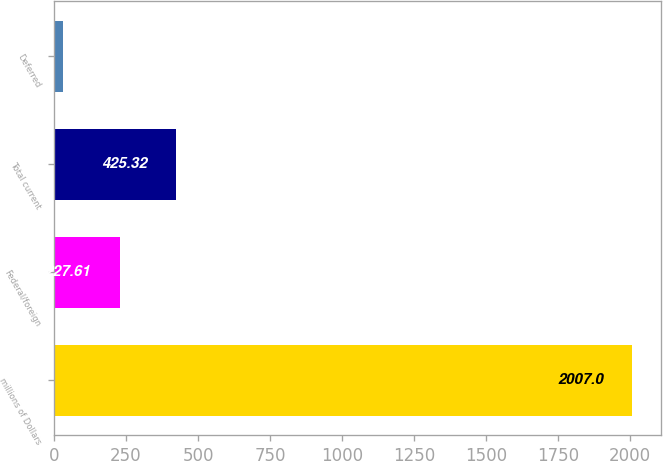Convert chart. <chart><loc_0><loc_0><loc_500><loc_500><bar_chart><fcel>millions of Dollars<fcel>Federal/foreign<fcel>Total current<fcel>Deferred<nl><fcel>2007<fcel>227.61<fcel>425.32<fcel>29.9<nl></chart> 